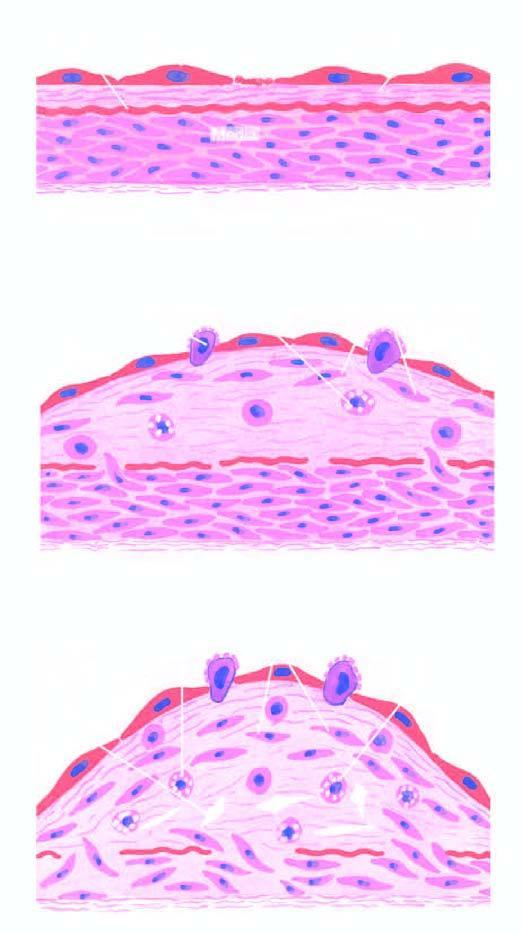what is explained by 'reaction-to-injury 'hypothesis?
Answer the question using a single word or phrase. Diagrammatic representation of pathogenesis of atherosclerosis 